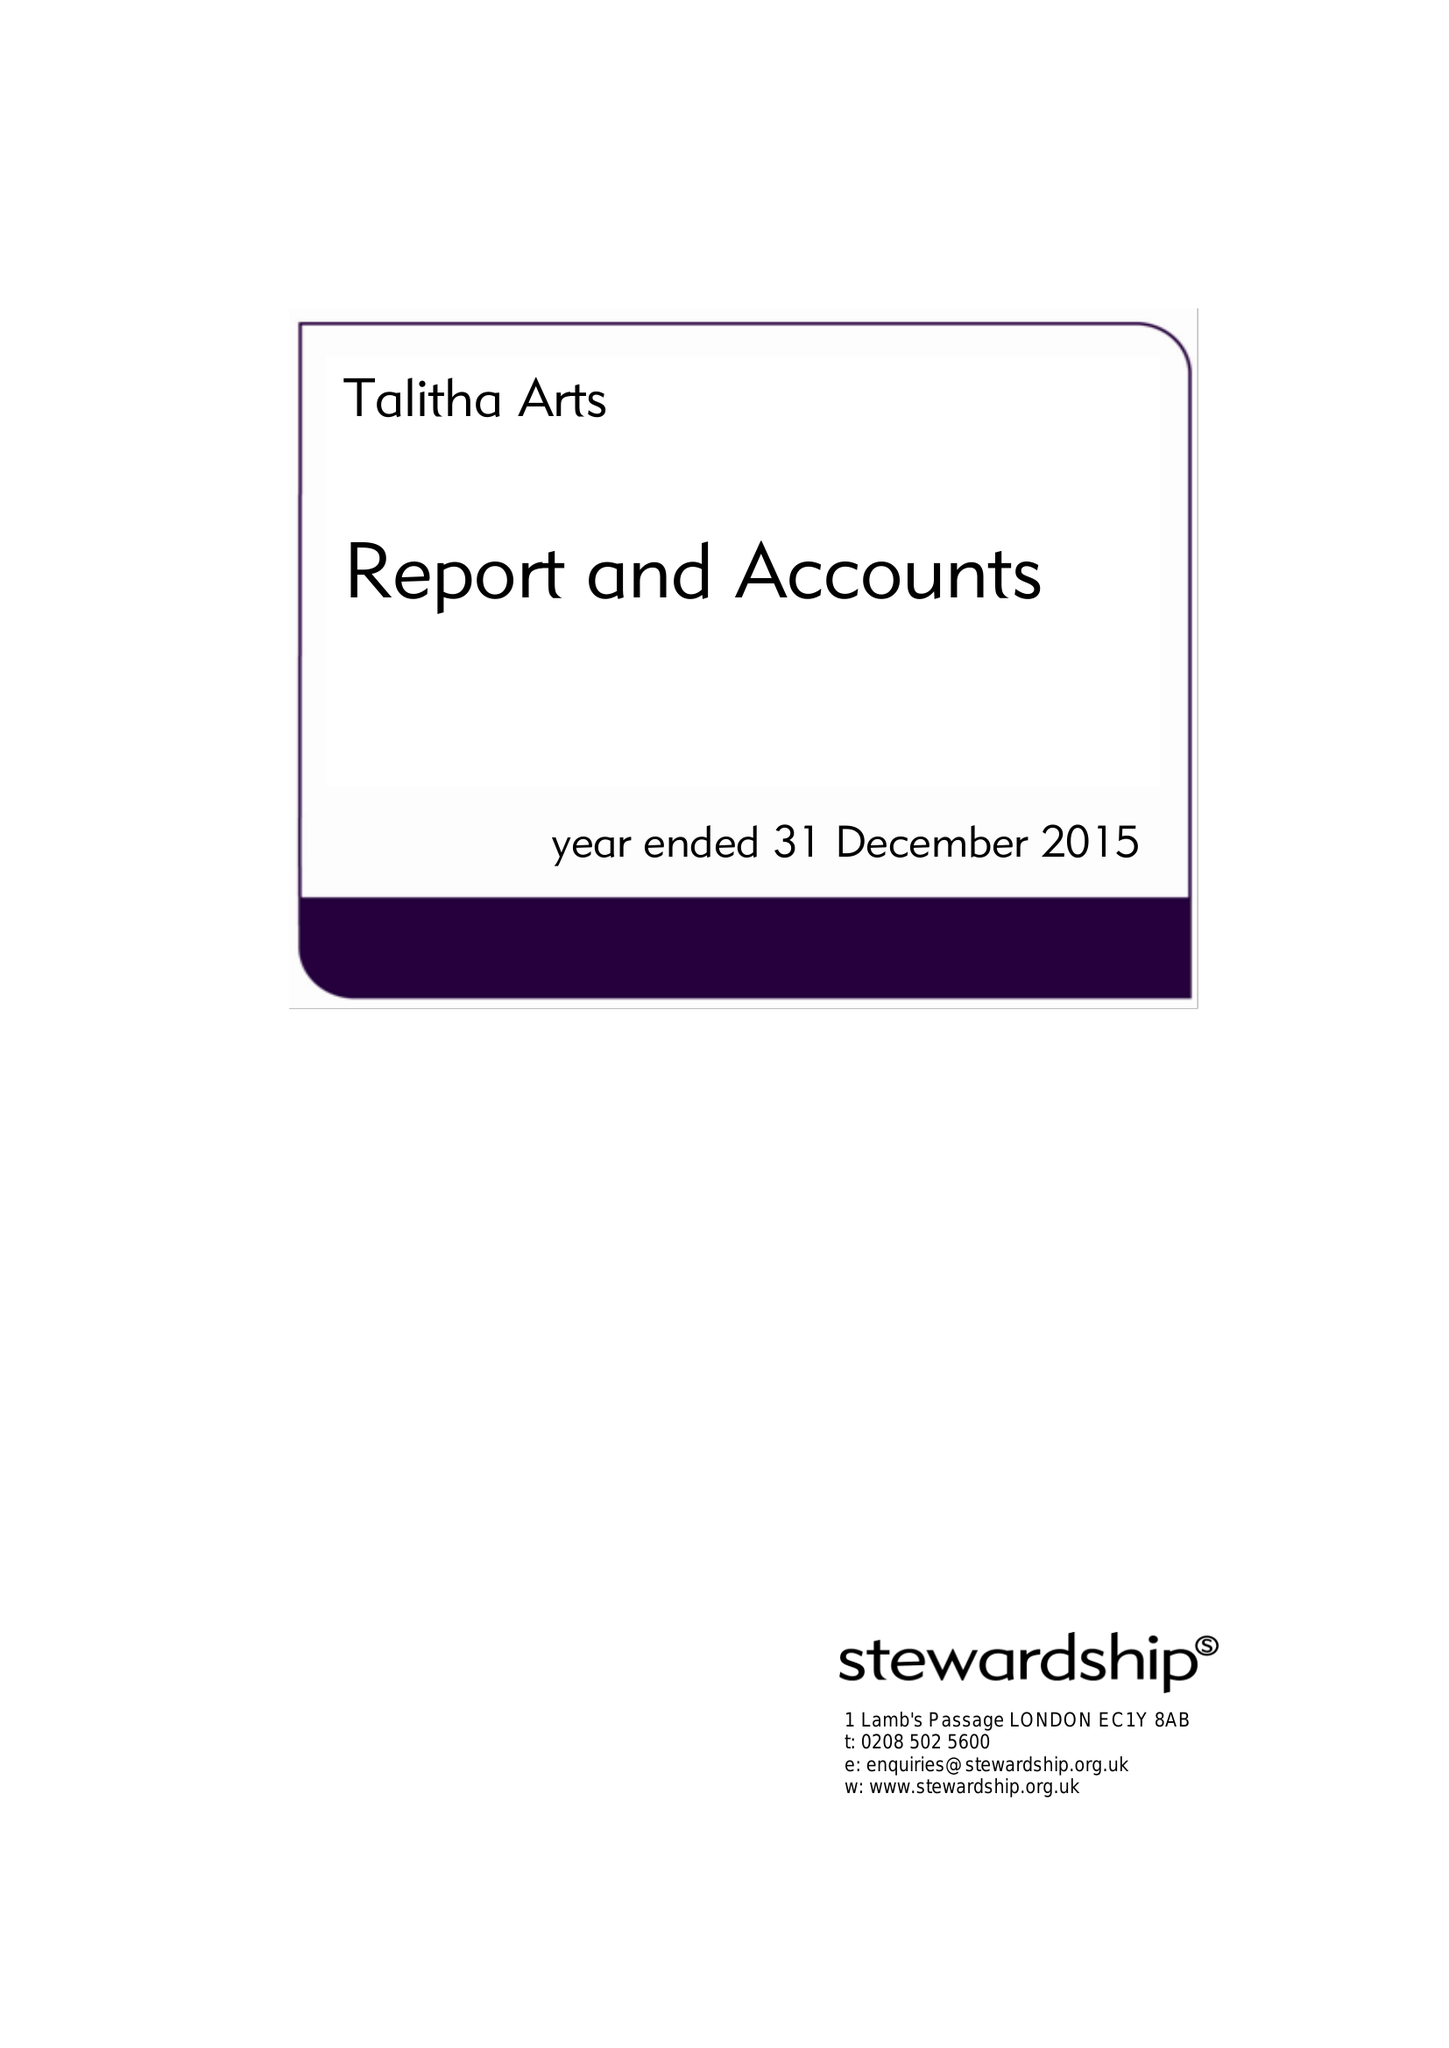What is the value for the address__post_town?
Answer the question using a single word or phrase. TEDDINGTON 